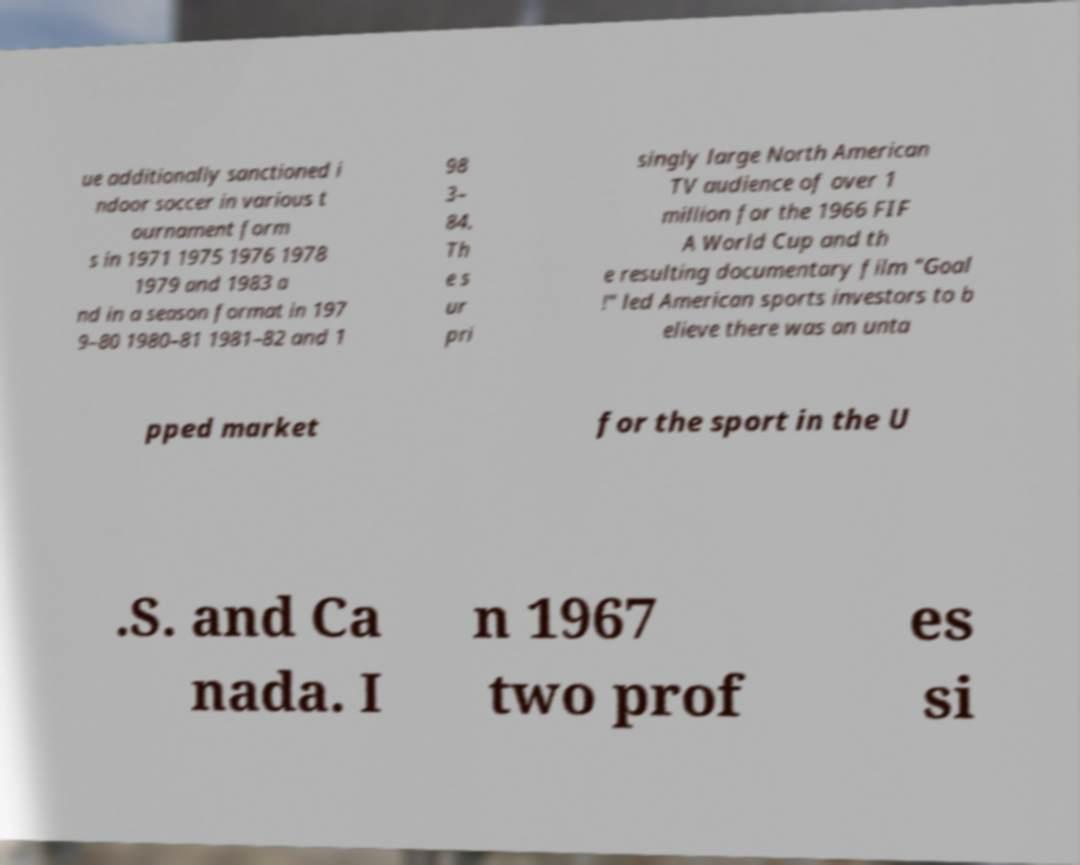Can you accurately transcribe the text from the provided image for me? ue additionally sanctioned i ndoor soccer in various t ournament form s in 1971 1975 1976 1978 1979 and 1983 a nd in a season format in 197 9–80 1980–81 1981–82 and 1 98 3– 84. Th e s ur pri singly large North American TV audience of over 1 million for the 1966 FIF A World Cup and th e resulting documentary film "Goal !" led American sports investors to b elieve there was an unta pped market for the sport in the U .S. and Ca nada. I n 1967 two prof es si 